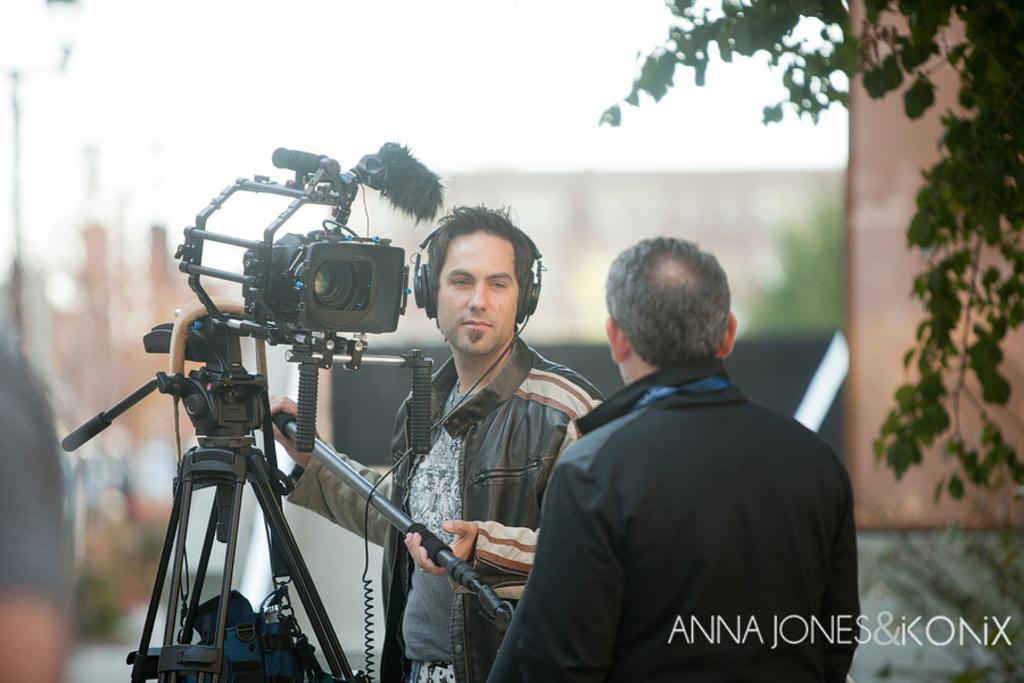Please provide a concise description of this image. There is a person standing wearing a black jacket and also he is holding a video camera and also he is wearing a headset looking on to a man wearing black jacket. In the background there is a branch of a tree. 